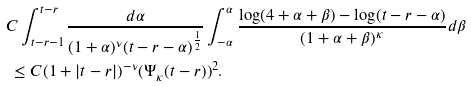Convert formula to latex. <formula><loc_0><loc_0><loc_500><loc_500>& C \int _ { t - r - 1 } ^ { t - r } \frac { d \alpha } { ( 1 + \alpha ) ^ { \nu } ( t - r - \alpha ) ^ { \frac { 1 } { 2 } } } \int _ { - \alpha } ^ { \alpha } \frac { \log ( 4 + \alpha + \beta ) - \log ( t - r - \alpha ) } { ( 1 + \alpha + \beta ) ^ { \kappa } } d \beta \\ & \ \leq C ( 1 + | t - r | ) ^ { - \nu } ( \Psi _ { \kappa } ( t - r ) ) ^ { 2 } .</formula> 